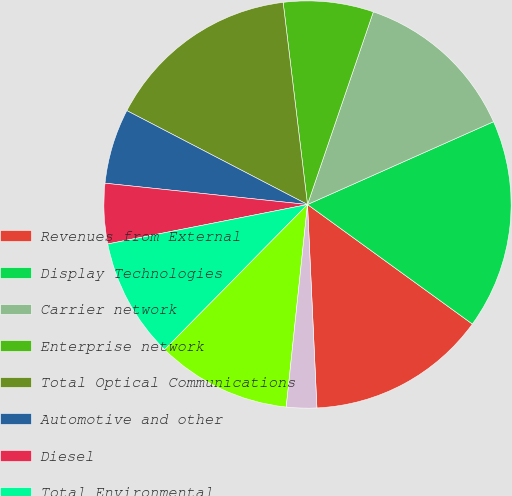Convert chart to OTSL. <chart><loc_0><loc_0><loc_500><loc_500><pie_chart><fcel>Revenues from External<fcel>Display Technologies<fcel>Carrier network<fcel>Enterprise network<fcel>Total Optical Communications<fcel>Automotive and other<fcel>Diesel<fcel>Total Environmental<fcel>Corning Gorilla Glass<fcel>Advanced optics and other<nl><fcel>14.28%<fcel>16.65%<fcel>13.09%<fcel>7.15%<fcel>15.46%<fcel>5.96%<fcel>4.77%<fcel>9.52%<fcel>10.71%<fcel>2.4%<nl></chart> 